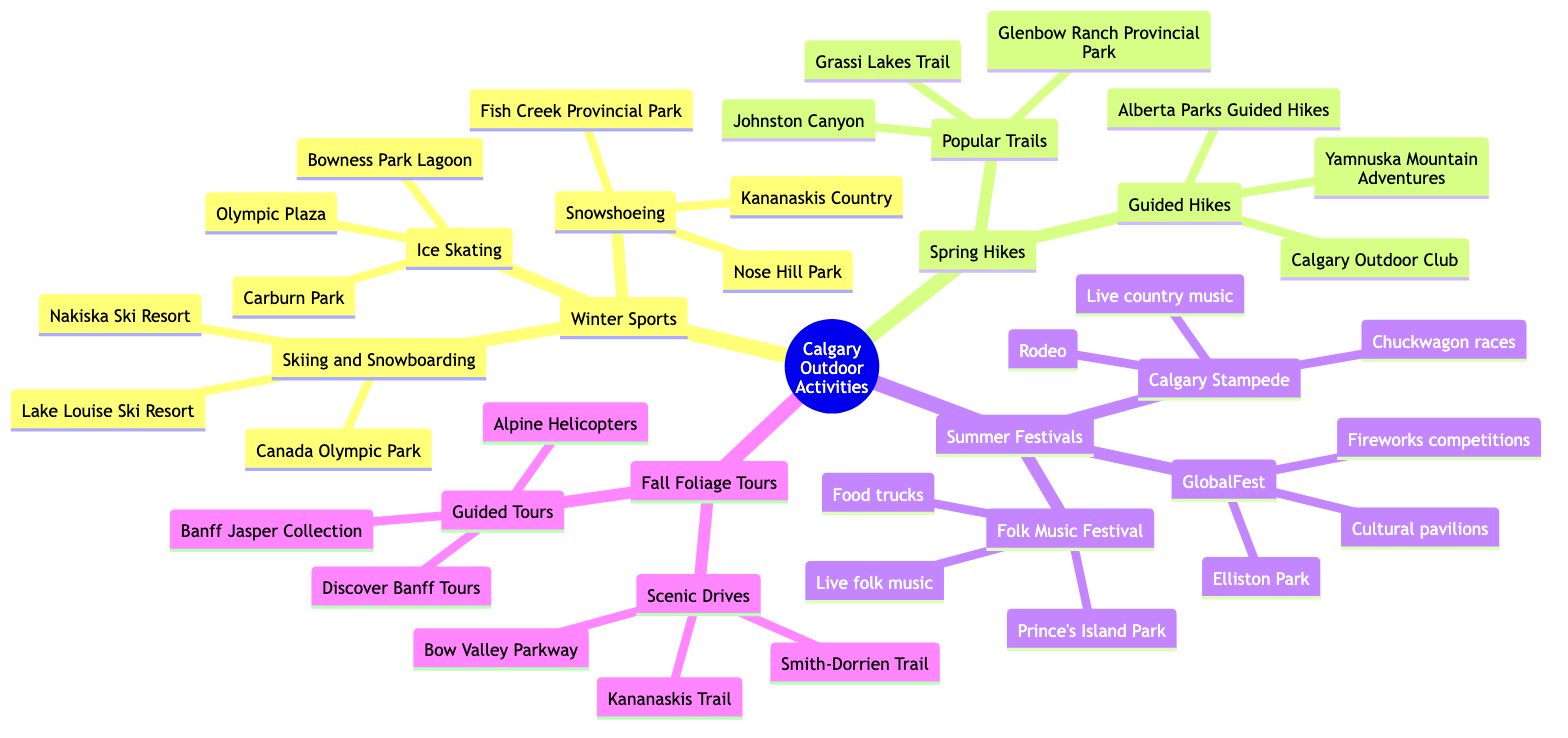What are the winter sports listed in the diagram? The diagram categorizes outdoor activities and lists "Skiing and Snowboarding", "Ice Skating", and "Snowshoeing" under the "Winter Sports" section.
Answer: Skiing and Snowboarding, Ice Skating, Snowshoeing How many locations are associated with Ice Skating? The Ice Skating section lists three specific locations: Olympic Plaza, Bowness Park Lagoon, and Carburn Park. Therefore, the count is based on these listed locations.
Answer: 3 Which park is mentioned as a location for summer festivals? The Folk Music Festival is specifically noted to take place at Prince's Island Park, indicating it as a summer festival location.
Answer: Prince's Island Park How many guided tours providers are listed in the Fall Foliage Tours section? Under the "Guided Tours" category of the Fall Foliage Tours, three providers are mentioned: Banff Jasper Collection, Discover Banff Tours, and Alpine Helicopters. The answer is derived by counting these listed providers.
Answer: 3 Which winter sports activity is associated with Kananaskis Country? The Snowshoeing category mentions Kananaskis Country as one of the locations for this activity, showing its association clearly.
Answer: Snowshoeing What unique features are listed for GlobalFest? The features for GlobalFest are outlined as follows: Fireworks competitions, Cultural pavilions, and Ethnic food stands, showcasing the type of activities at this summer festival.
Answer: Fireworks competitions, Cultural pavilions, Ethnic food stands In the Spring Hikes, what topics are covered during guided hikes? The "Guided Hikes" category lists topics such as Geology, Local history, and Ecology, which are covered during these hikes. This provides insight into the content of the guided experiences.
Answer: Geology, Local history, Ecology What is a common activity listed in both Scenic Drives and Popular Trails categories? Both categories offer opportunities for "Photography," which can be enjoyed while taking scenic drives or hiking on popular trails, indicating a shared activity across these outdoor experiences.
Answer: Photography 